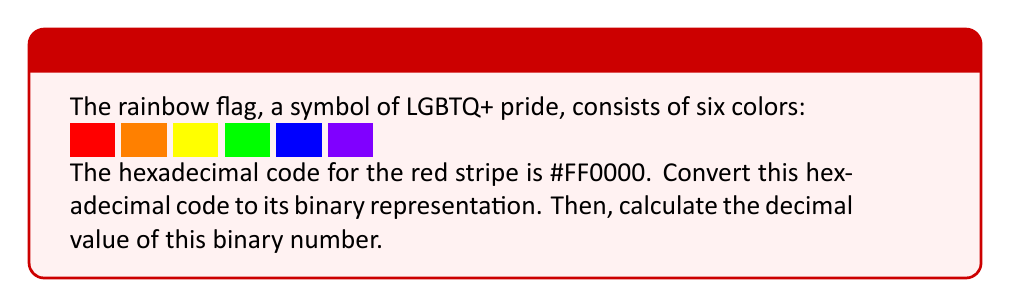Provide a solution to this math problem. Let's approach this step-by-step:

1) The hexadecimal code #FF0000 represents the color red in RGB format.

2) To convert hexadecimal to binary:
   FF = 1111 1111
   00 = 0000 0000
   00 = 0000 0000

3) Therefore, #FF0000 in binary is:
   $$111111110000000000000000$$

4) To convert this binary number to decimal, we can use the following method:
   $$(1 \times 2^{23}) + (1 \times 2^{22}) + (1 \times 2^{21}) + ... + (1 \times 2^{16}) + (0 \times 2^{15}) + ... + (0 \times 2^0)$$

5) Simplifying:
   $$2^{23} + 2^{22} + 2^{21} + 2^{20} + 2^{19} + 2^{18} + 2^{17} + 2^{16}$$

6) Calculating:
   $$8388608 + 4194304 + 2097152 + 1048576 + 524288 + 262144 + 131072 + 65536$$

7) Sum:
   $$16711680$$

Thus, the decimal representation of the binary number is 16711680.
Answer: 16711680 